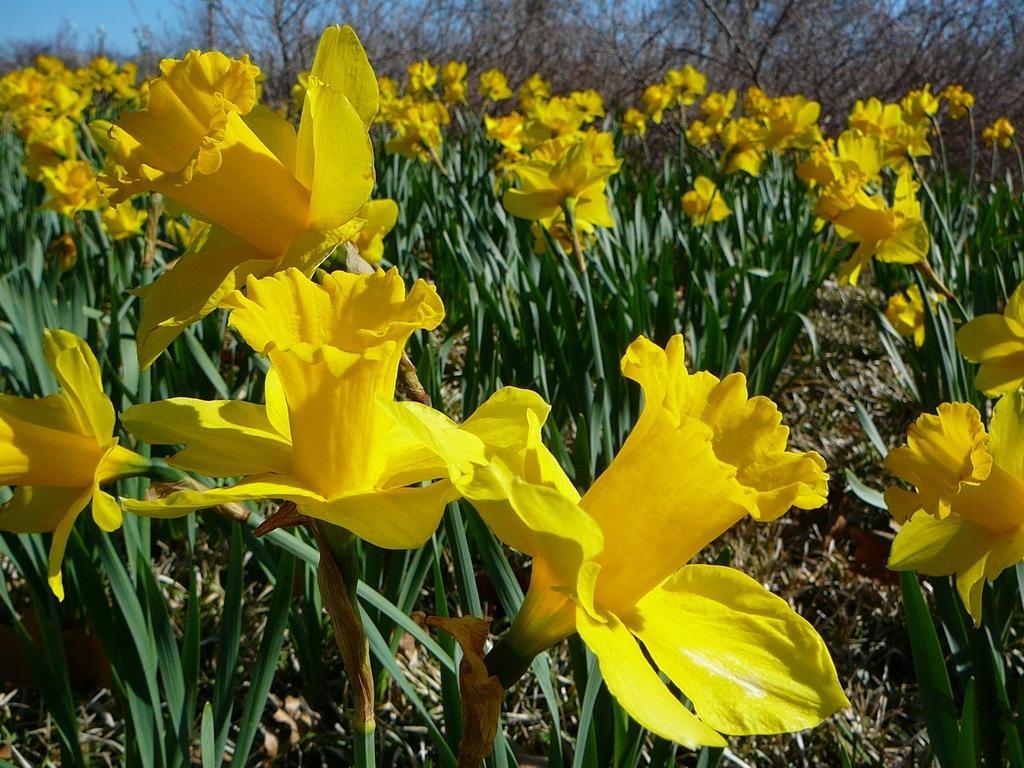Describe this image in one or two sentences. In this image we can see some flowers, plants, trees, also we can see the sky. 